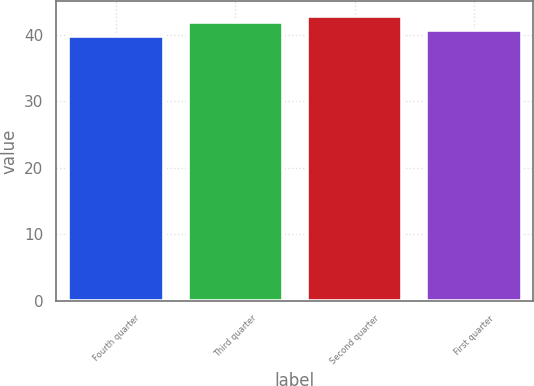Convert chart to OTSL. <chart><loc_0><loc_0><loc_500><loc_500><bar_chart><fcel>Fourth quarter<fcel>Third quarter<fcel>Second quarter<fcel>First quarter<nl><fcel>39.88<fcel>41.85<fcel>42.87<fcel>40.75<nl></chart> 